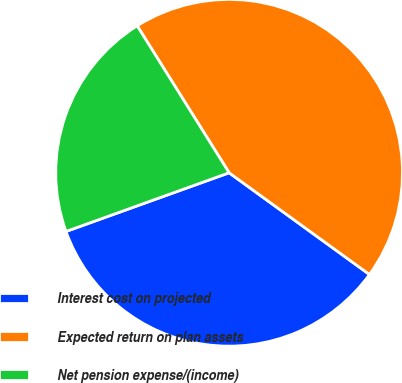<chart> <loc_0><loc_0><loc_500><loc_500><pie_chart><fcel>Interest cost on projected<fcel>Expected return on plan assets<fcel>Net pension expense/(income)<nl><fcel>34.52%<fcel>43.88%<fcel>21.6%<nl></chart> 